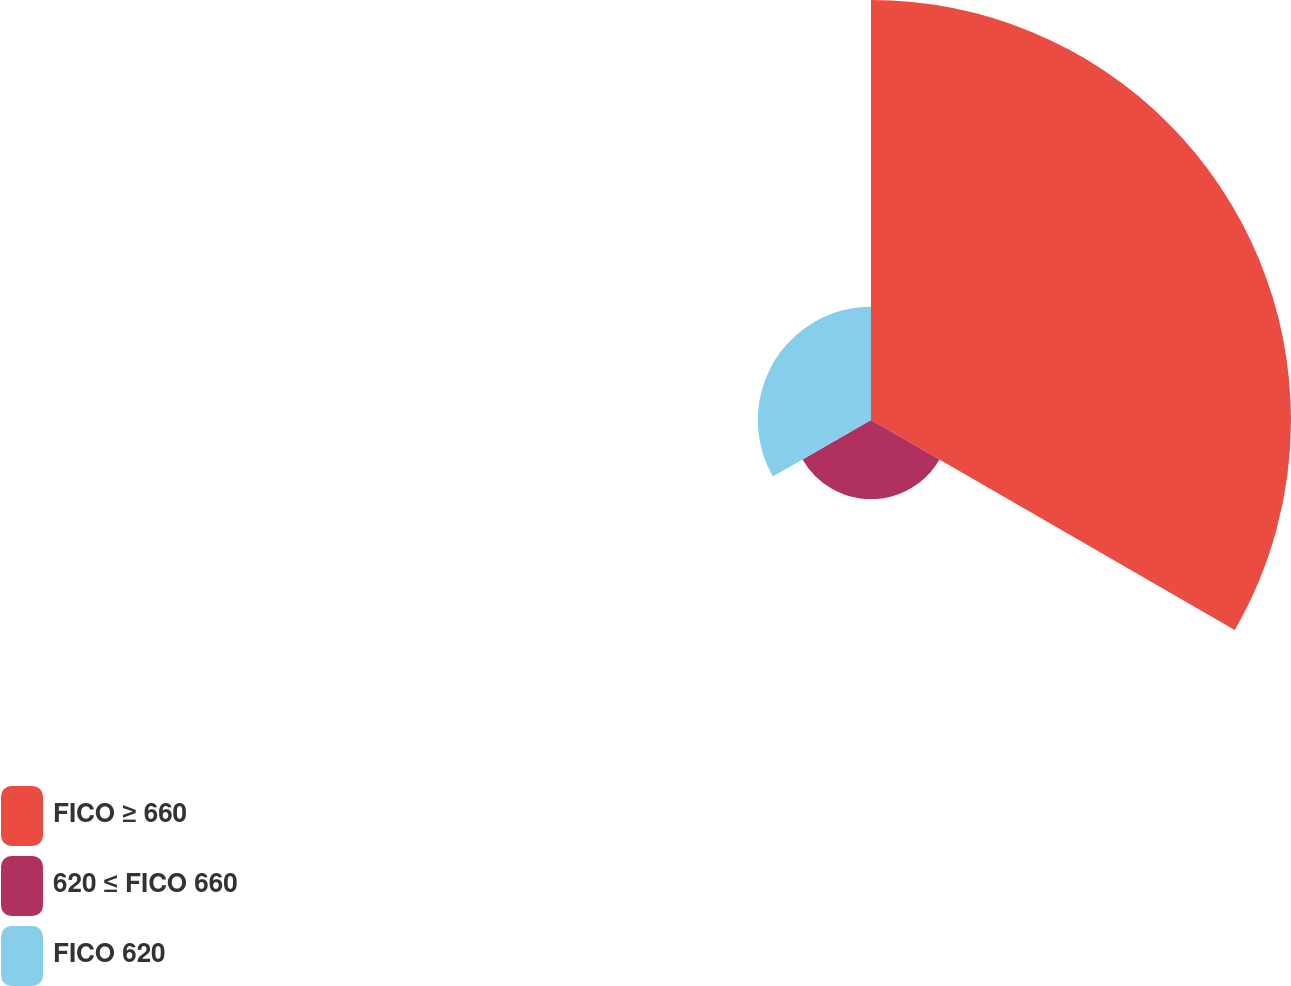Convert chart to OTSL. <chart><loc_0><loc_0><loc_500><loc_500><pie_chart><fcel>FICO ≥ 660<fcel>620 ≤ FICO 660<fcel>FICO 620<nl><fcel>68.59%<fcel>12.92%<fcel>18.49%<nl></chart> 